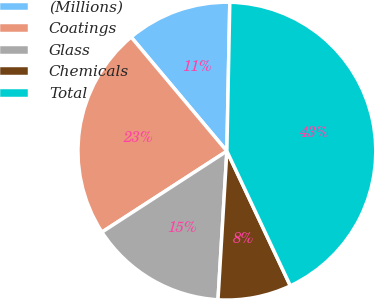Convert chart. <chart><loc_0><loc_0><loc_500><loc_500><pie_chart><fcel>(Millions)<fcel>Coatings<fcel>Glass<fcel>Chemicals<fcel>Total<nl><fcel>11.43%<fcel>23.04%<fcel>14.9%<fcel>7.96%<fcel>42.68%<nl></chart> 